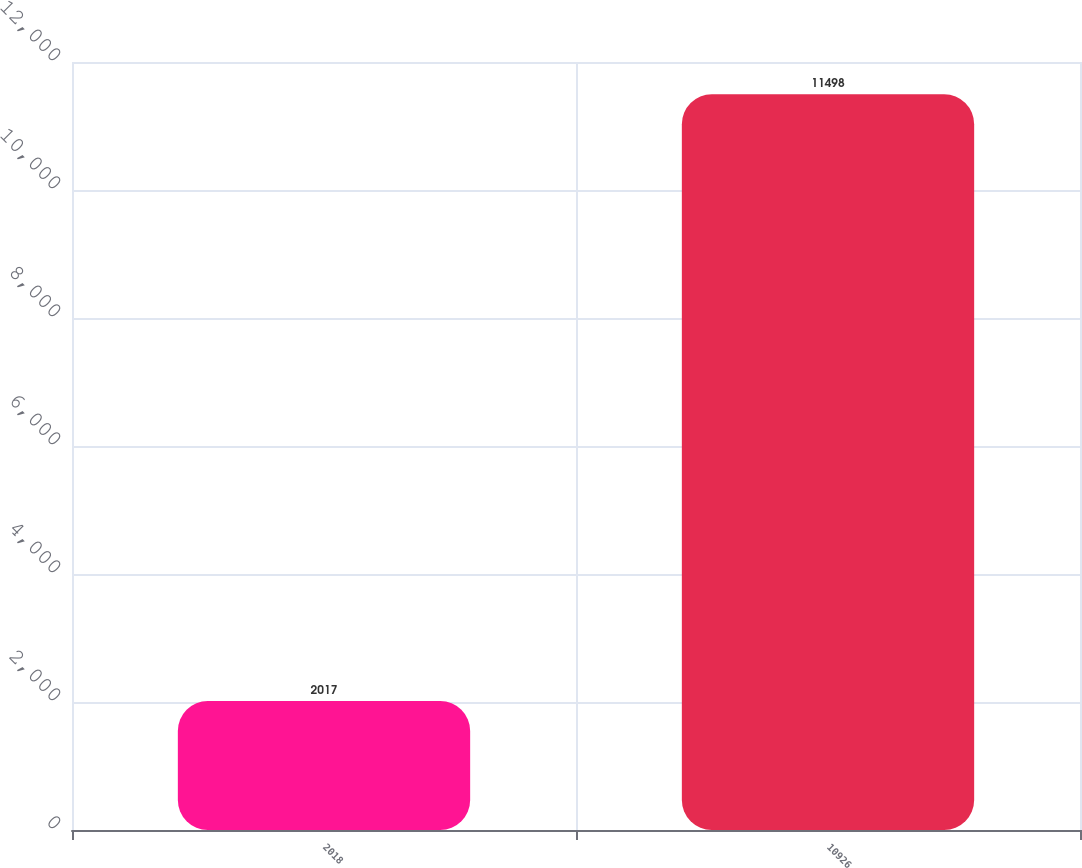<chart> <loc_0><loc_0><loc_500><loc_500><bar_chart><fcel>2018<fcel>10926<nl><fcel>2017<fcel>11498<nl></chart> 